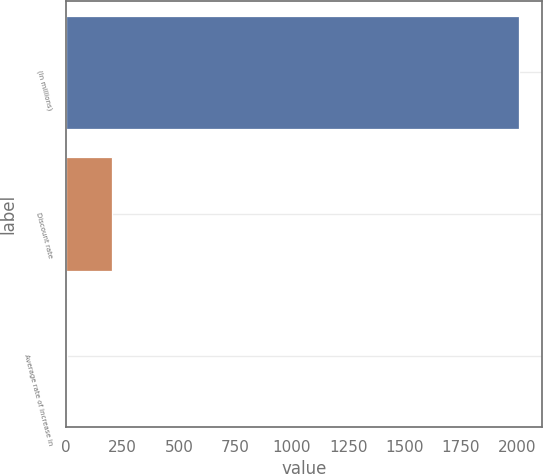<chart> <loc_0><loc_0><loc_500><loc_500><bar_chart><fcel>(In millions)<fcel>Discount rate<fcel>Average rate of increase in<nl><fcel>2009<fcel>203.82<fcel>3.24<nl></chart> 